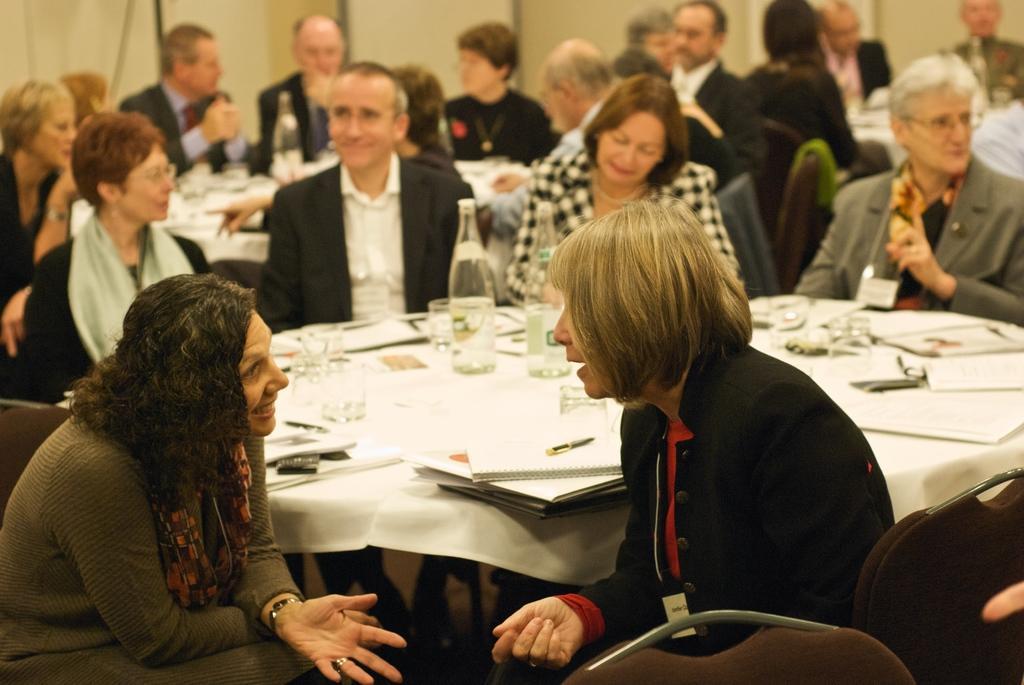In one or two sentences, can you explain what this image depicts? The image is taken in an event. In the center of the image there is a table. There are many people sitting around the tables. There are files, glasses, bottles, papers placed on the table. In the background there is a wall. 